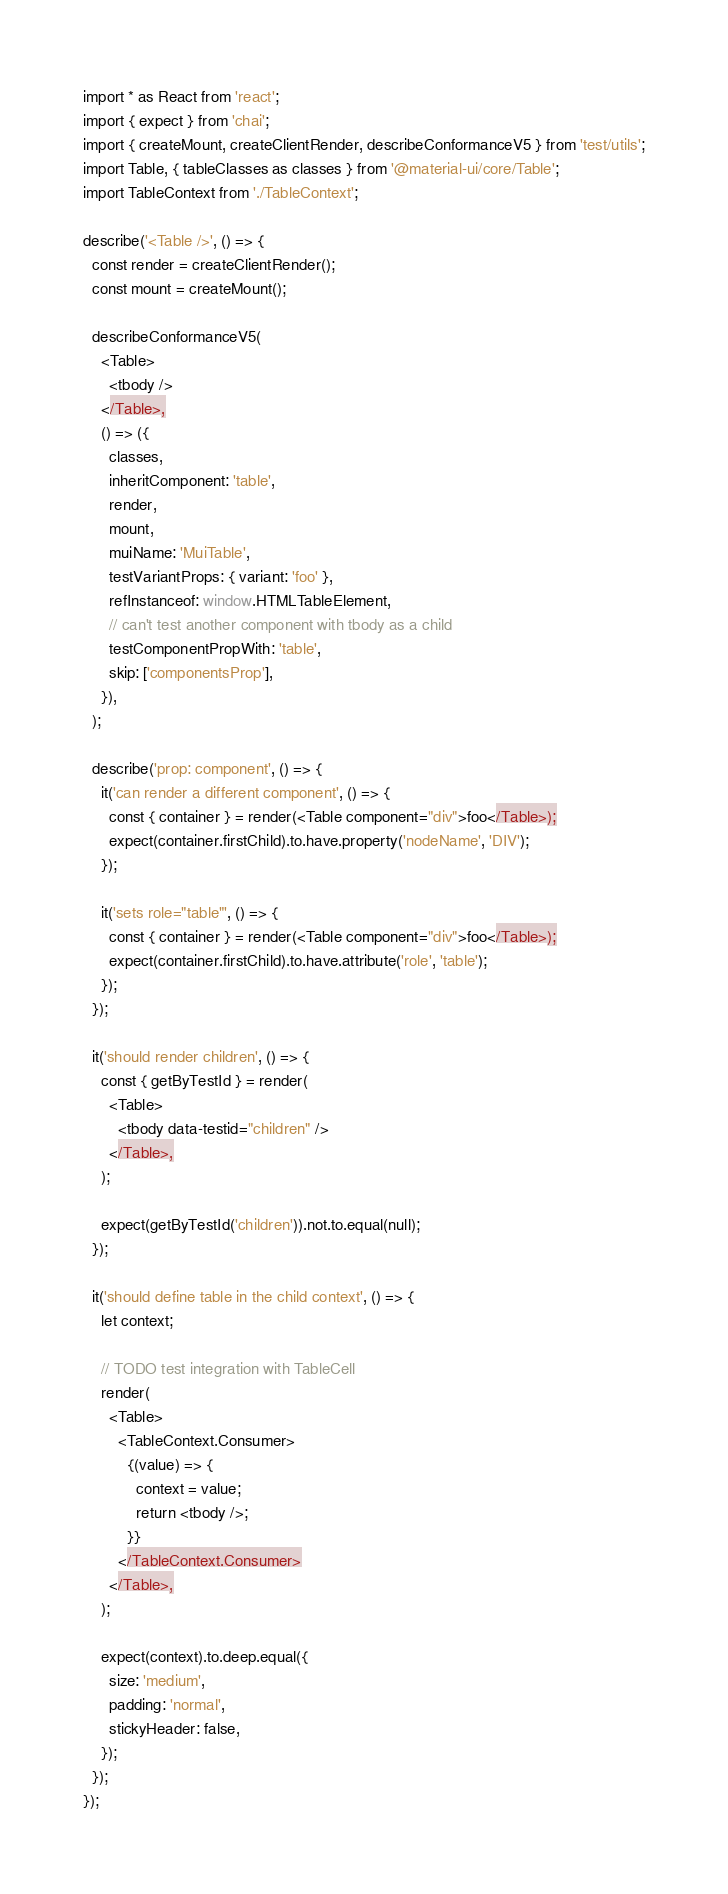<code> <loc_0><loc_0><loc_500><loc_500><_JavaScript_>import * as React from 'react';
import { expect } from 'chai';
import { createMount, createClientRender, describeConformanceV5 } from 'test/utils';
import Table, { tableClasses as classes } from '@material-ui/core/Table';
import TableContext from './TableContext';

describe('<Table />', () => {
  const render = createClientRender();
  const mount = createMount();

  describeConformanceV5(
    <Table>
      <tbody />
    </Table>,
    () => ({
      classes,
      inheritComponent: 'table',
      render,
      mount,
      muiName: 'MuiTable',
      testVariantProps: { variant: 'foo' },
      refInstanceof: window.HTMLTableElement,
      // can't test another component with tbody as a child
      testComponentPropWith: 'table',
      skip: ['componentsProp'],
    }),
  );

  describe('prop: component', () => {
    it('can render a different component', () => {
      const { container } = render(<Table component="div">foo</Table>);
      expect(container.firstChild).to.have.property('nodeName', 'DIV');
    });

    it('sets role="table"', () => {
      const { container } = render(<Table component="div">foo</Table>);
      expect(container.firstChild).to.have.attribute('role', 'table');
    });
  });

  it('should render children', () => {
    const { getByTestId } = render(
      <Table>
        <tbody data-testid="children" />
      </Table>,
    );

    expect(getByTestId('children')).not.to.equal(null);
  });

  it('should define table in the child context', () => {
    let context;

    // TODO test integration with TableCell
    render(
      <Table>
        <TableContext.Consumer>
          {(value) => {
            context = value;
            return <tbody />;
          }}
        </TableContext.Consumer>
      </Table>,
    );

    expect(context).to.deep.equal({
      size: 'medium',
      padding: 'normal',
      stickyHeader: false,
    });
  });
});
</code> 